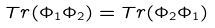Convert formula to latex. <formula><loc_0><loc_0><loc_500><loc_500>T r ( \Phi _ { 1 } \Phi _ { 2 } ) = T r ( \Phi _ { 2 } \Phi _ { 1 } )</formula> 